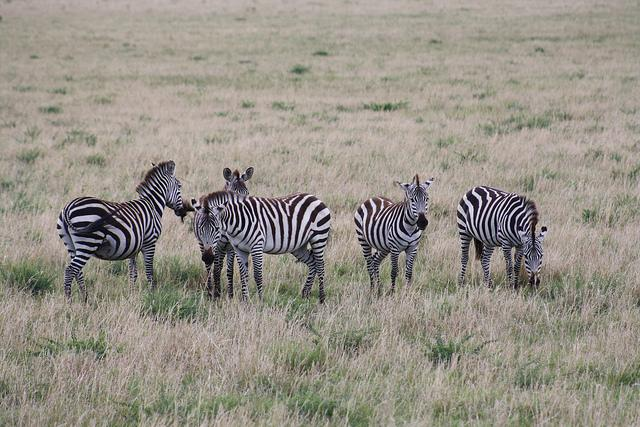How many zebras are standing in the middle of the open field? five 